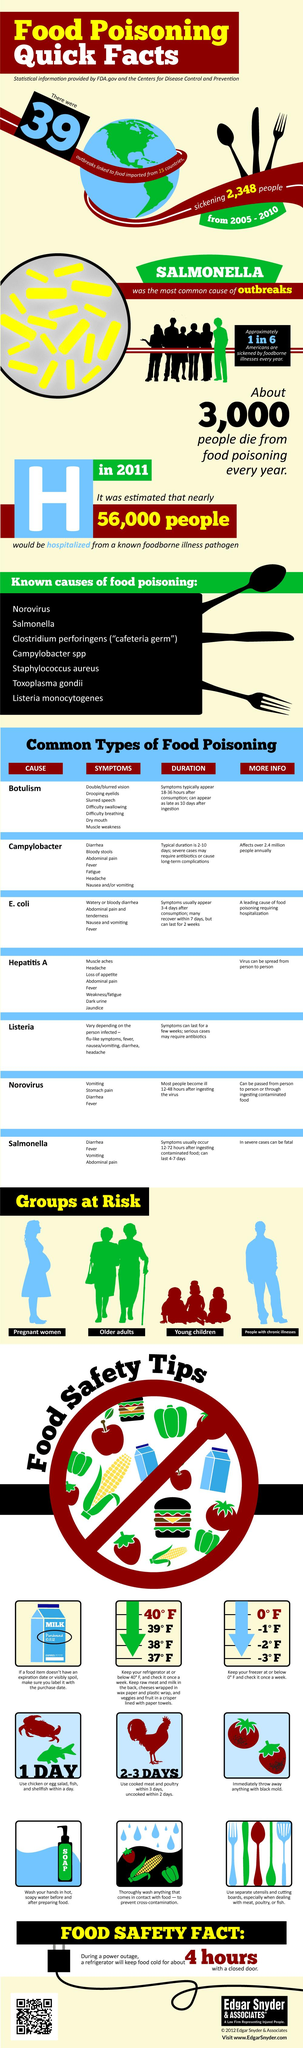Outline some significant characteristics in this image. Hepatitis A is a type of food poisoning that can cause jaundice as a symptom. Drooping eyelids are a symptom of botulism, a type of food poisoning characterized by muscle weakness and paralysis. The age groups of older adults and young children are at a greater risk of food poisoning. Salmonella can cause a type of food poisoning that can be fatal in severe cases. Salmonella is the second most common cause of food poisoning, according to known causes. 